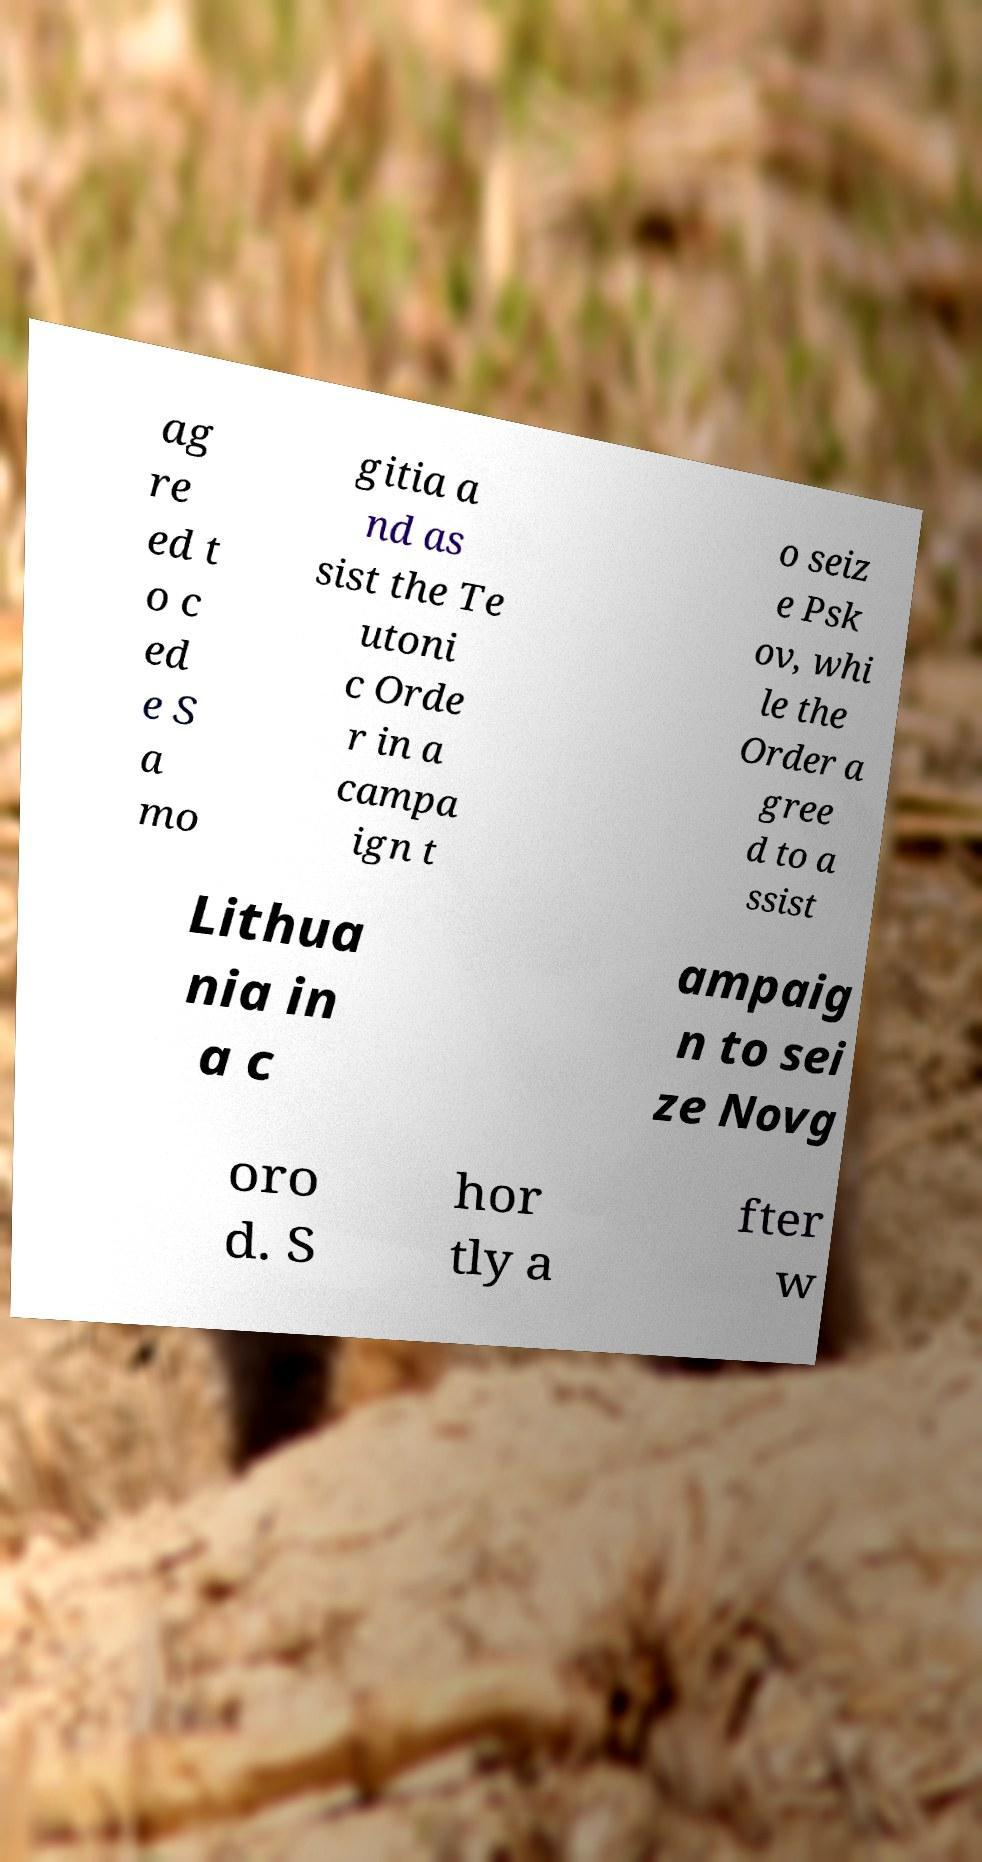Please identify and transcribe the text found in this image. ag re ed t o c ed e S a mo gitia a nd as sist the Te utoni c Orde r in a campa ign t o seiz e Psk ov, whi le the Order a gree d to a ssist Lithua nia in a c ampaig n to sei ze Novg oro d. S hor tly a fter w 